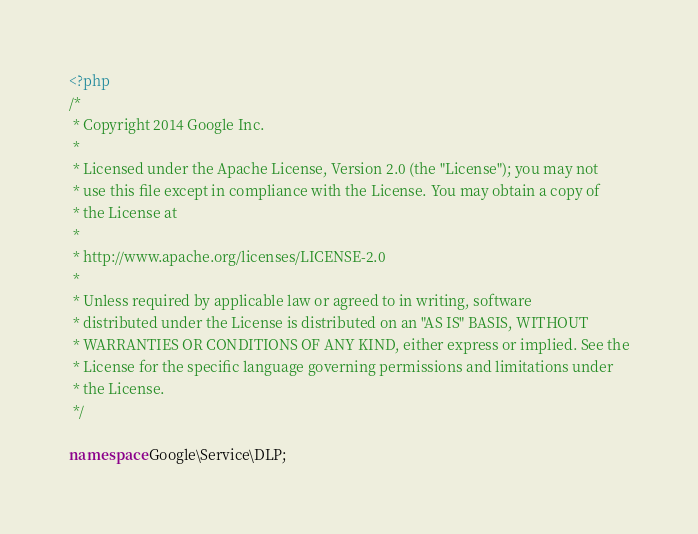<code> <loc_0><loc_0><loc_500><loc_500><_PHP_><?php
/*
 * Copyright 2014 Google Inc.
 *
 * Licensed under the Apache License, Version 2.0 (the "License"); you may not
 * use this file except in compliance with the License. You may obtain a copy of
 * the License at
 *
 * http://www.apache.org/licenses/LICENSE-2.0
 *
 * Unless required by applicable law or agreed to in writing, software
 * distributed under the License is distributed on an "AS IS" BASIS, WITHOUT
 * WARRANTIES OR CONDITIONS OF ANY KIND, either express or implied. See the
 * License for the specific language governing permissions and limitations under
 * the License.
 */

namespace Google\Service\DLP;
</code> 